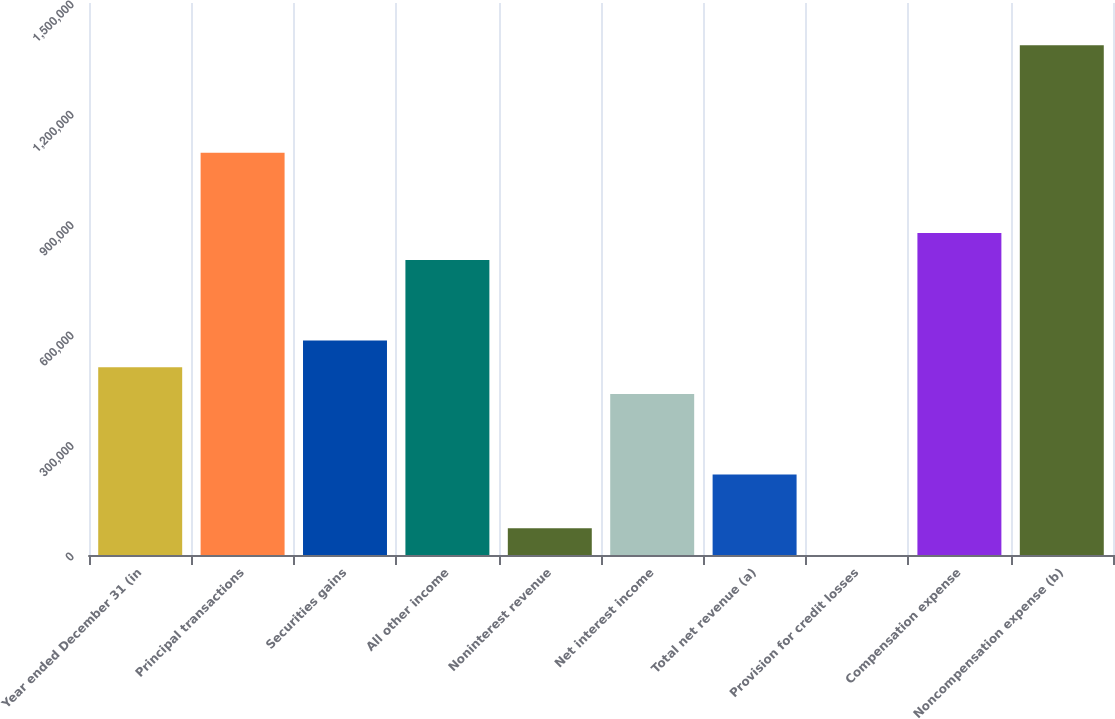<chart> <loc_0><loc_0><loc_500><loc_500><bar_chart><fcel>Year ended December 31 (in<fcel>Principal transactions<fcel>Securities gains<fcel>All other income<fcel>Noninterest revenue<fcel>Net interest income<fcel>Total net revenue (a)<fcel>Provision for credit losses<fcel>Compensation expense<fcel>Noncompensation expense (b)<nl><fcel>510259<fcel>1.09337e+06<fcel>583147<fcel>801814<fcel>72925.8<fcel>437370<fcel>218703<fcel>37<fcel>874703<fcel>1.38492e+06<nl></chart> 